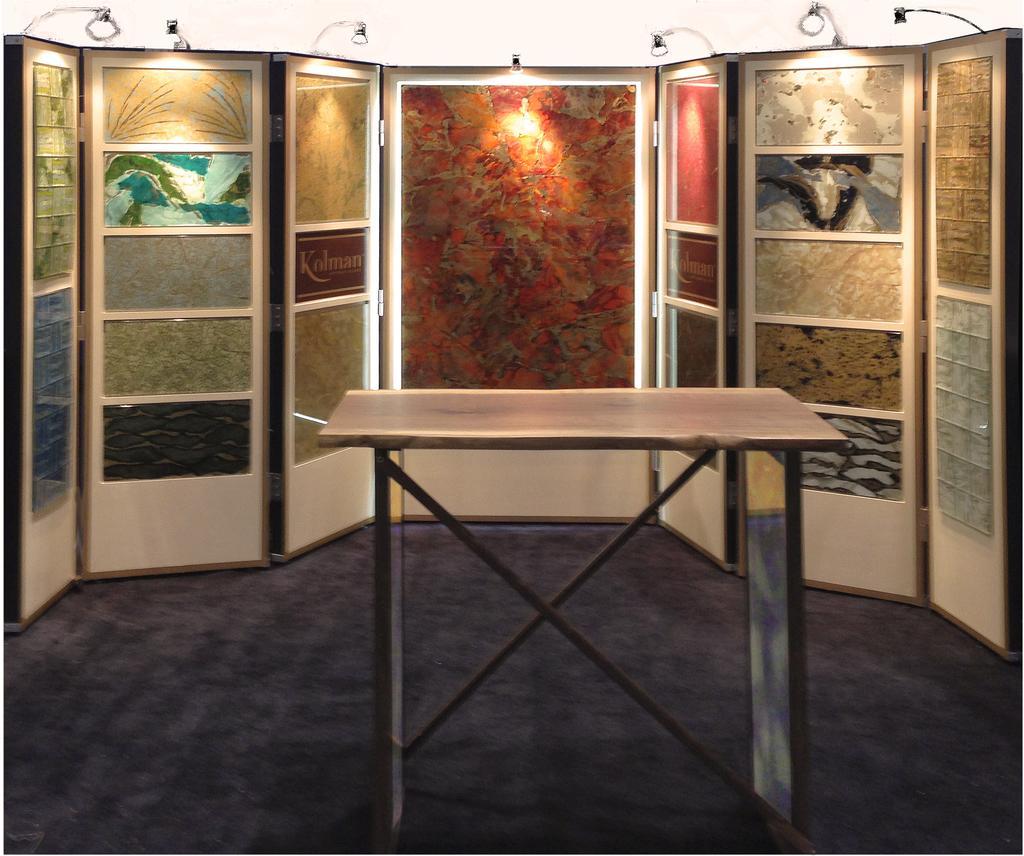Can you describe this image briefly? In this image in the middle there is a table. In the background there are many paintings on the wall. On the top there are lights. 